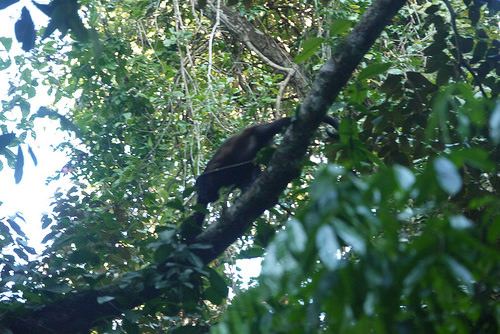<image>
Is there a bird above the stem? No. The bird is not positioned above the stem. The vertical arrangement shows a different relationship. 